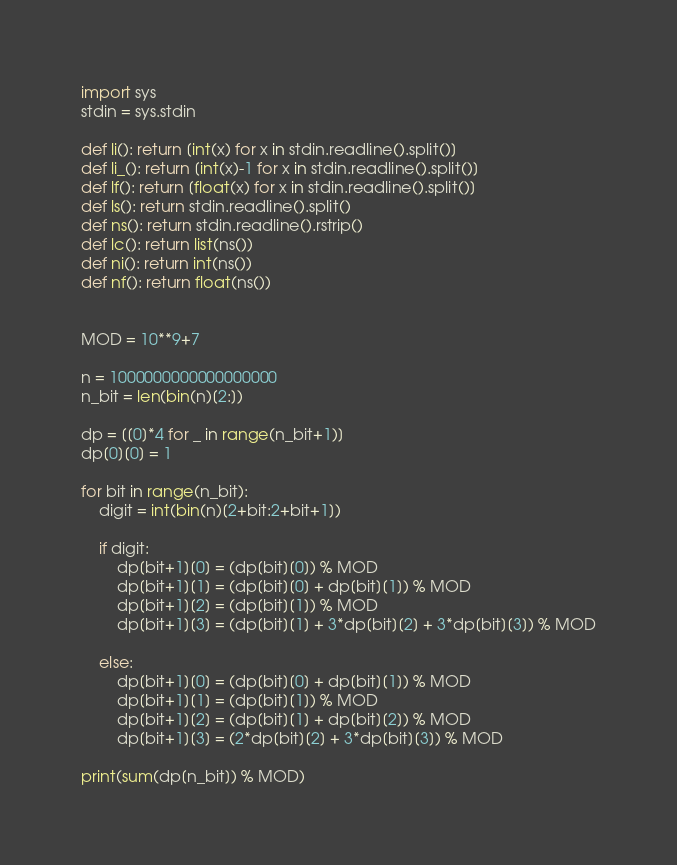Convert code to text. <code><loc_0><loc_0><loc_500><loc_500><_Python_>import sys
stdin = sys.stdin

def li(): return [int(x) for x in stdin.readline().split()]
def li_(): return [int(x)-1 for x in stdin.readline().split()]
def lf(): return [float(x) for x in stdin.readline().split()]
def ls(): return stdin.readline().split()
def ns(): return stdin.readline().rstrip()
def lc(): return list(ns())
def ni(): return int(ns())
def nf(): return float(ns())


MOD = 10**9+7

n = 1000000000000000000
n_bit = len(bin(n)[2:])

dp = [[0]*4 for _ in range(n_bit+1)]
dp[0][0] = 1

for bit in range(n_bit):
    digit = int(bin(n)[2+bit:2+bit+1])
    
    if digit:
        dp[bit+1][0] = (dp[bit][0]) % MOD
        dp[bit+1][1] = (dp[bit][0] + dp[bit][1]) % MOD
        dp[bit+1][2] = (dp[bit][1]) % MOD
        dp[bit+1][3] = (dp[bit][1] + 3*dp[bit][2] + 3*dp[bit][3]) % MOD
        
    else:
        dp[bit+1][0] = (dp[bit][0] + dp[bit][1]) % MOD
        dp[bit+1][1] = (dp[bit][1]) % MOD
        dp[bit+1][2] = (dp[bit][1] + dp[bit][2]) % MOD
        dp[bit+1][3] = (2*dp[bit][2] + 3*dp[bit][3]) % MOD
        
print(sum(dp[n_bit]) % MOD)</code> 